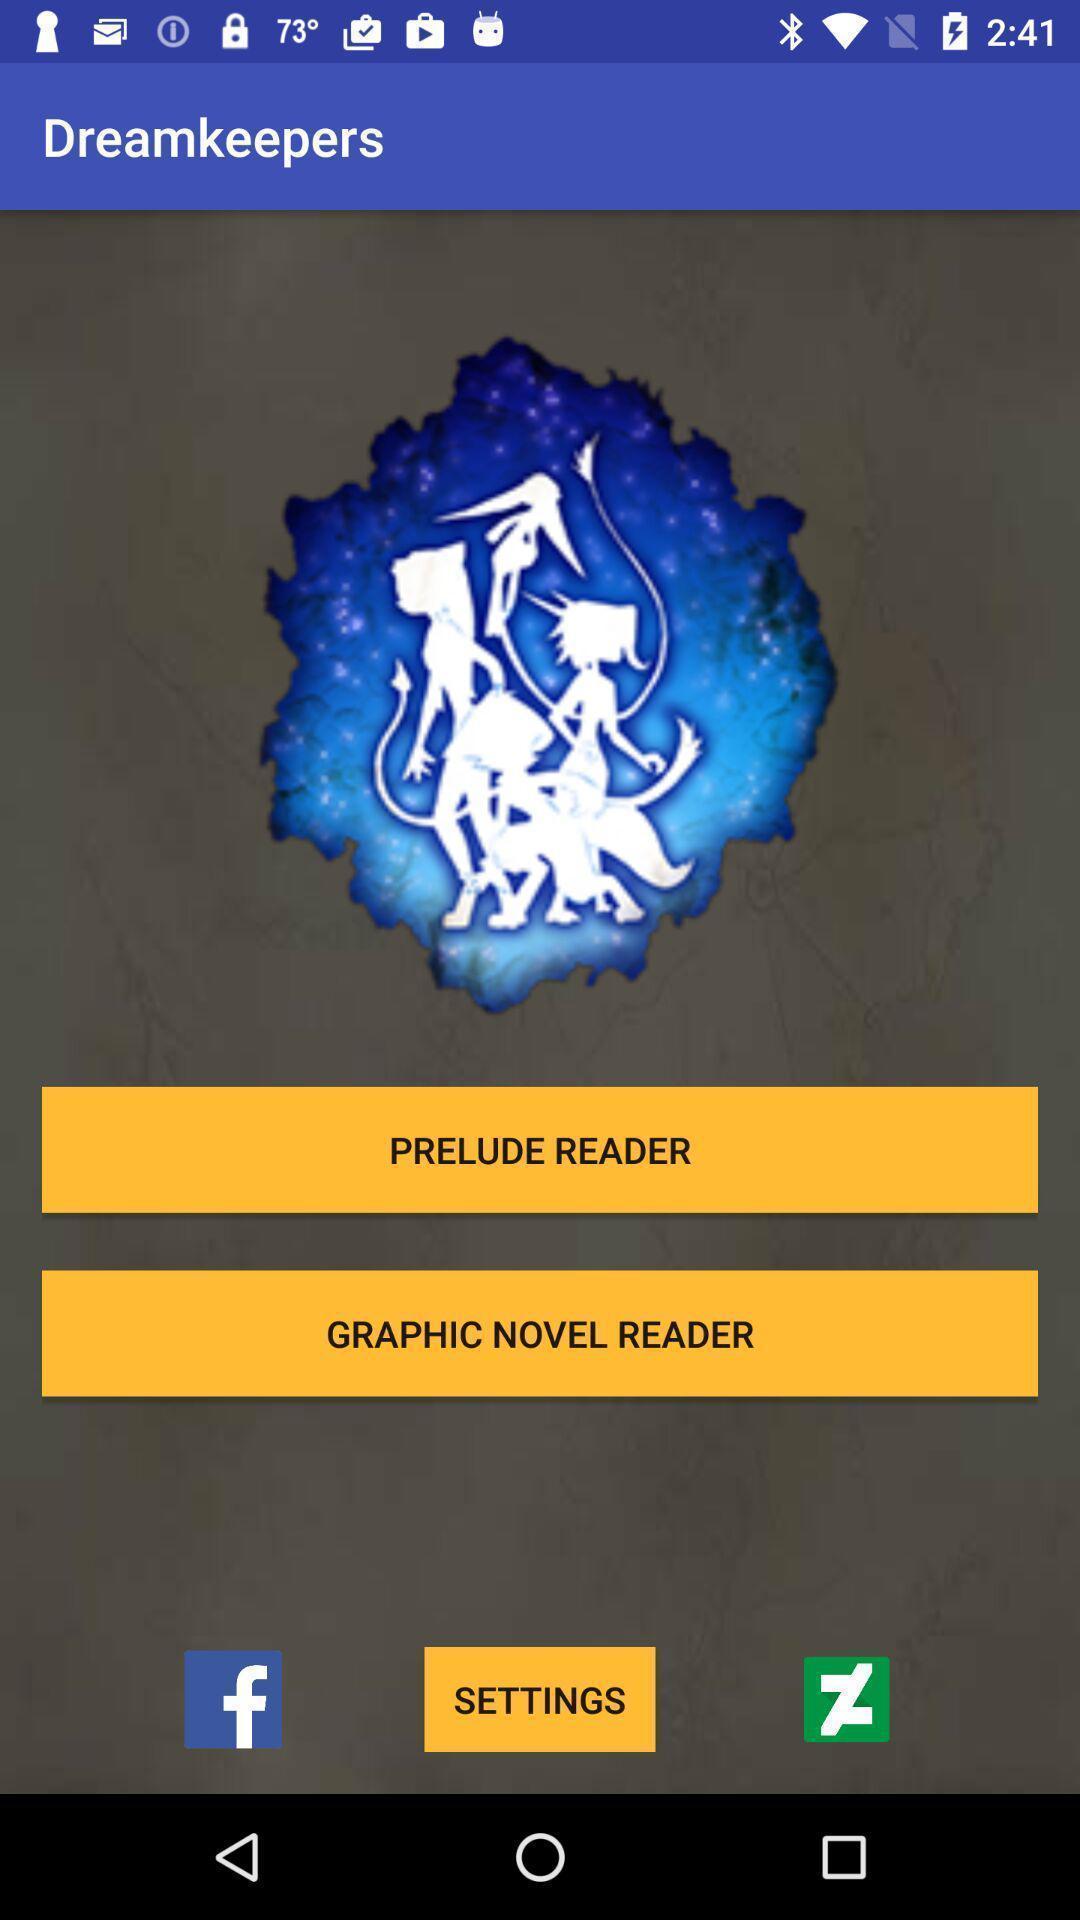Summarize the main components in this picture. Menu page of dream keepers. 